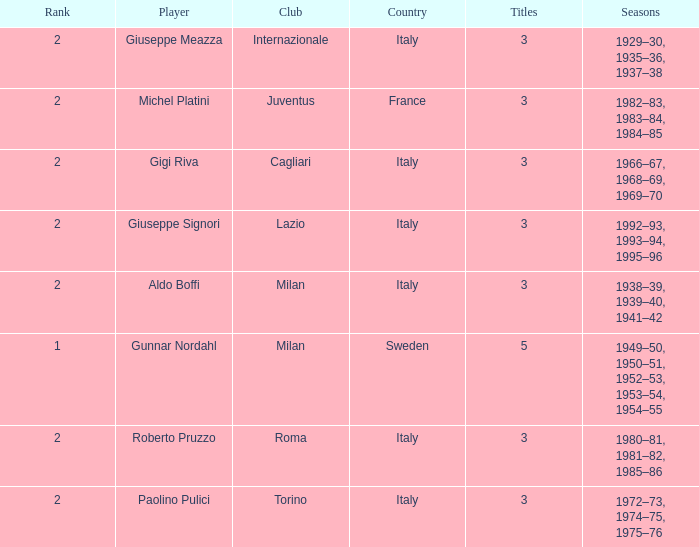What player is ranked 2 and played in the seasons of 1982–83, 1983–84, 1984–85? Michel Platini. 